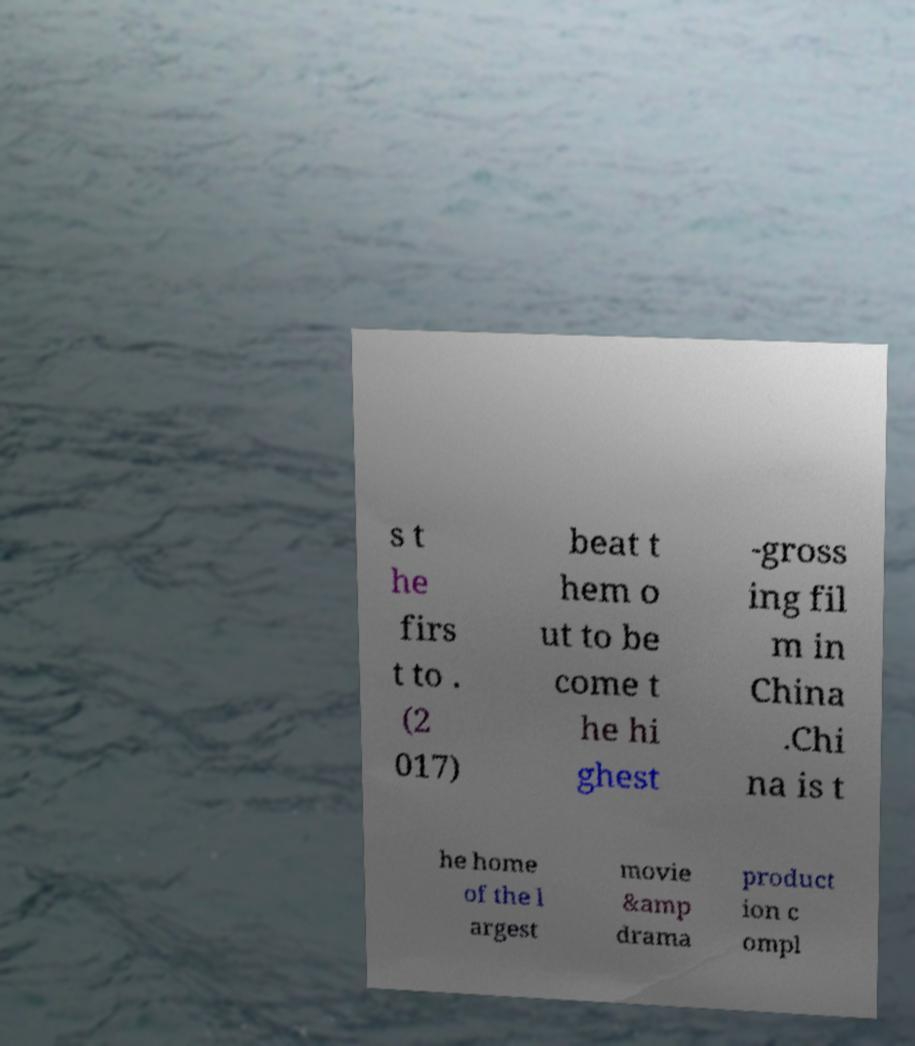I need the written content from this picture converted into text. Can you do that? s t he firs t to . (2 017) beat t hem o ut to be come t he hi ghest -gross ing fil m in China .Chi na is t he home of the l argest movie &amp drama product ion c ompl 